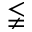<formula> <loc_0><loc_0><loc_500><loc_500>\lneqq</formula> 